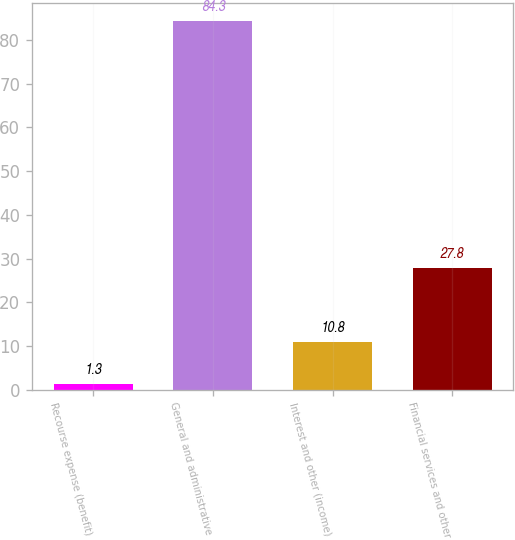<chart> <loc_0><loc_0><loc_500><loc_500><bar_chart><fcel>Recourse expense (benefit)<fcel>General and administrative<fcel>Interest and other (income)<fcel>Financial services and other<nl><fcel>1.3<fcel>84.3<fcel>10.8<fcel>27.8<nl></chart> 